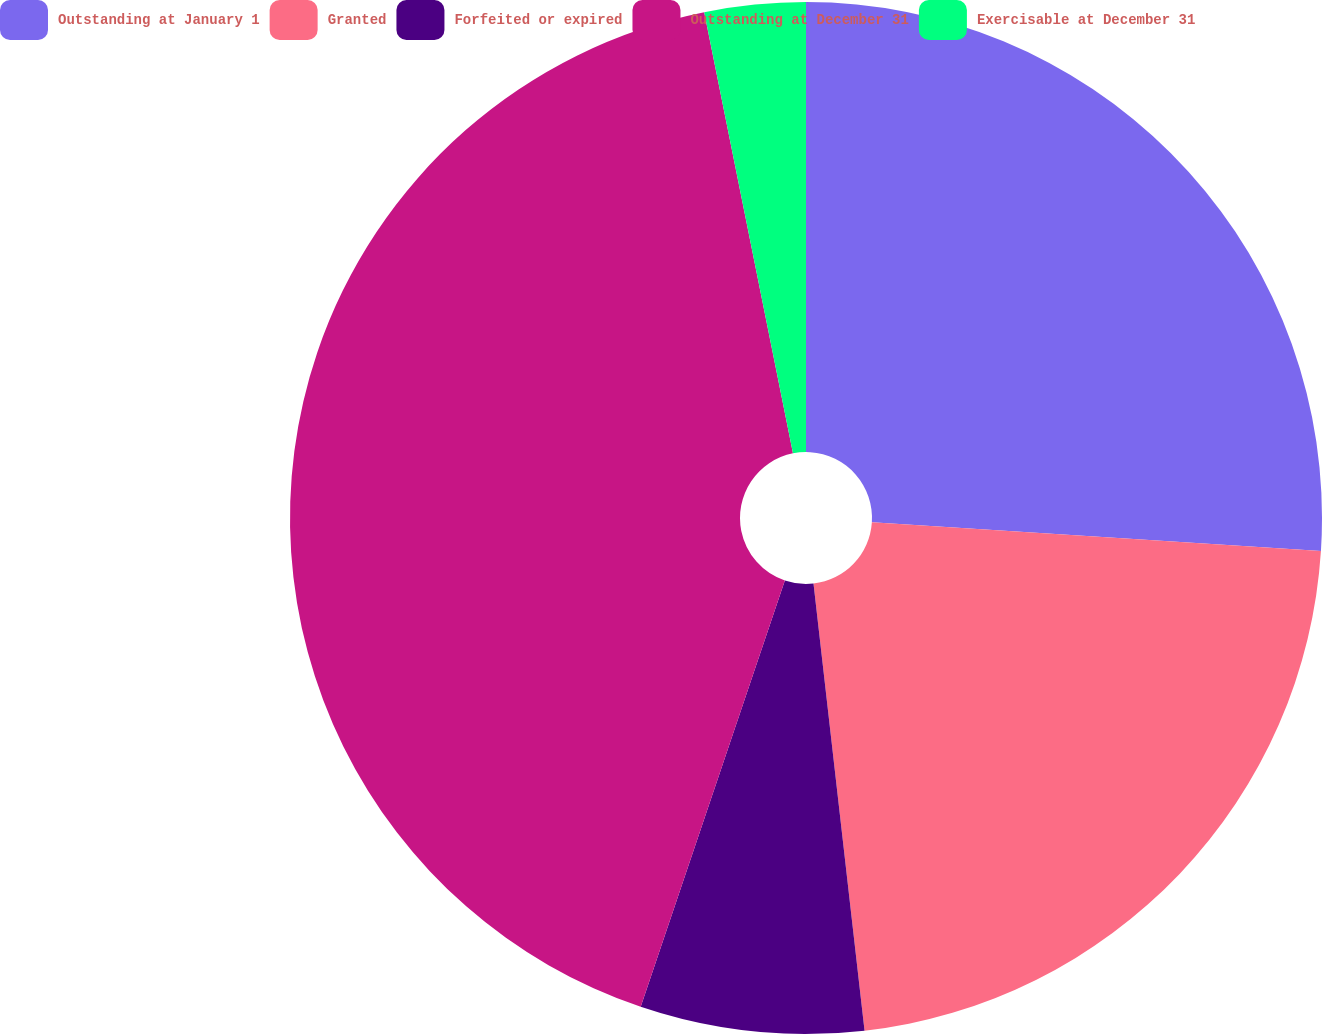Convert chart. <chart><loc_0><loc_0><loc_500><loc_500><pie_chart><fcel>Outstanding at January 1<fcel>Granted<fcel>Forfeited or expired<fcel>Outstanding at December 31<fcel>Exercisable at December 31<nl><fcel>26.02%<fcel>22.17%<fcel>7.0%<fcel>41.65%<fcel>3.16%<nl></chart> 